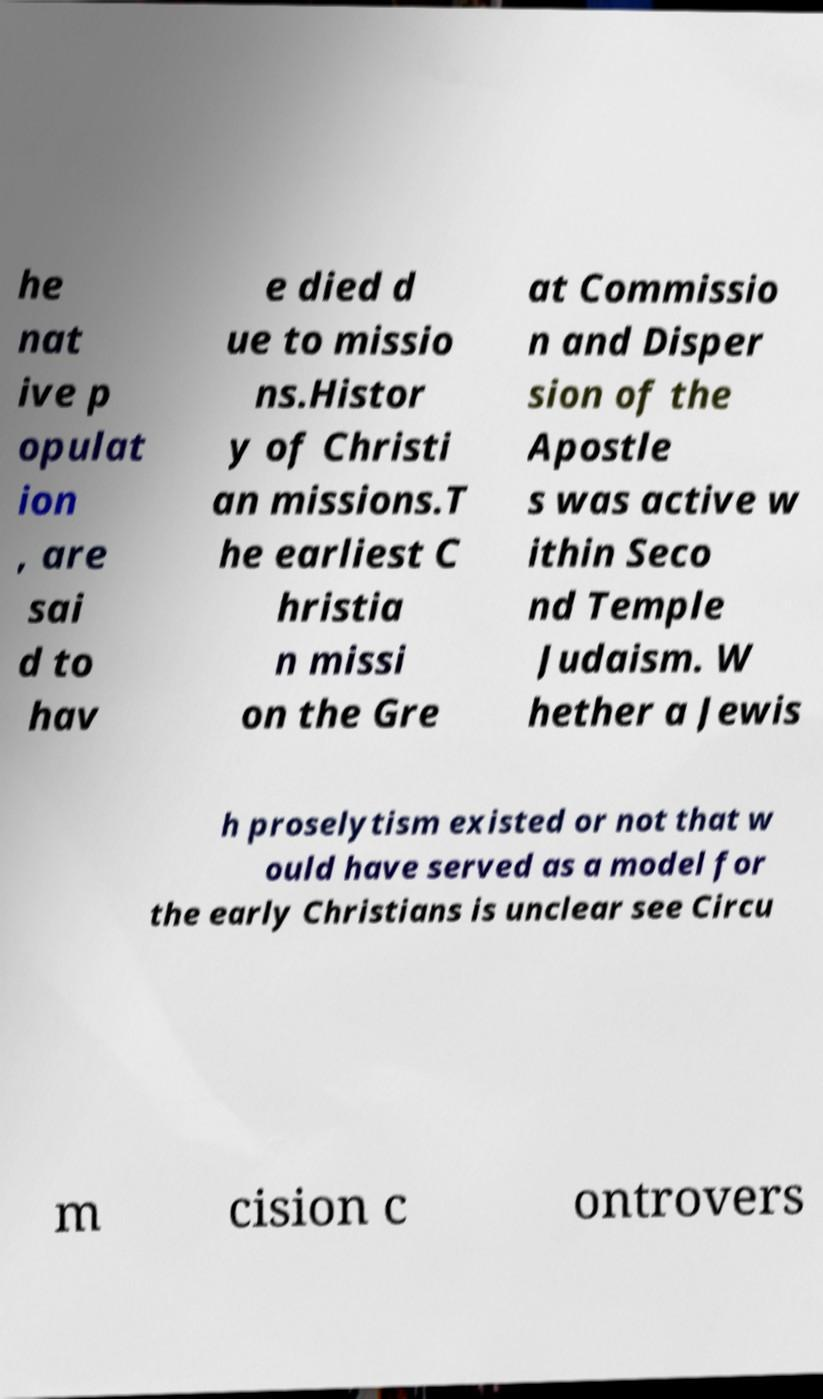Can you accurately transcribe the text from the provided image for me? he nat ive p opulat ion , are sai d to hav e died d ue to missio ns.Histor y of Christi an missions.T he earliest C hristia n missi on the Gre at Commissio n and Disper sion of the Apostle s was active w ithin Seco nd Temple Judaism. W hether a Jewis h proselytism existed or not that w ould have served as a model for the early Christians is unclear see Circu m cision c ontrovers 